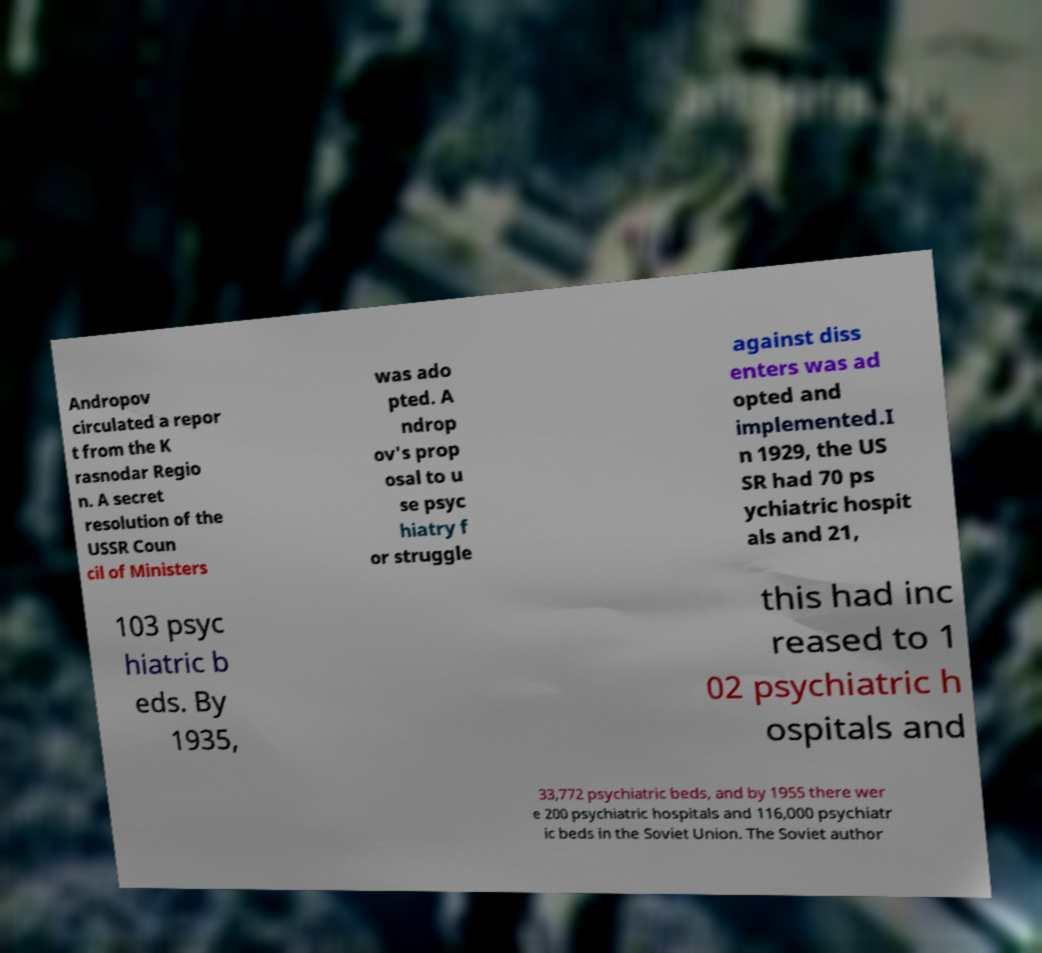Could you extract and type out the text from this image? Andropov circulated a repor t from the K rasnodar Regio n. A secret resolution of the USSR Coun cil of Ministers was ado pted. A ndrop ov's prop osal to u se psyc hiatry f or struggle against diss enters was ad opted and implemented.I n 1929, the US SR had 70 ps ychiatric hospit als and 21, 103 psyc hiatric b eds. By 1935, this had inc reased to 1 02 psychiatric h ospitals and 33,772 psychiatric beds, and by 1955 there wer e 200 psychiatric hospitals and 116,000 psychiatr ic beds in the Soviet Union. The Soviet author 